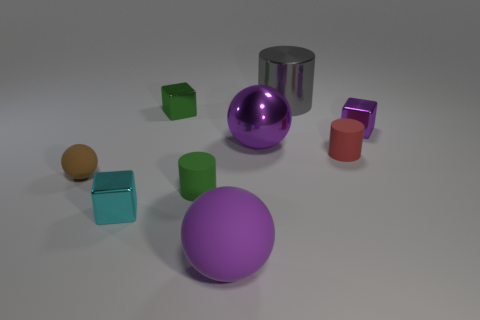What shape is the thing on the right side of the red matte cylinder?
Keep it short and to the point. Cube. There is a matte cylinder behind the cylinder in front of the red object; what color is it?
Provide a succinct answer. Red. What color is the tiny rubber thing that is the same shape as the big purple metallic thing?
Ensure brevity in your answer.  Brown. What number of shiny things are the same color as the metal sphere?
Make the answer very short. 1. There is a tiny sphere; is its color the same as the small matte cylinder behind the tiny brown rubber thing?
Your answer should be very brief. No. The small metal thing that is in front of the tiny green shiny thing and left of the red rubber object has what shape?
Keep it short and to the point. Cube. The small cube in front of the tiny green object that is in front of the cylinder that is right of the big gray shiny cylinder is made of what material?
Keep it short and to the point. Metal. Is the number of tiny brown objects behind the tiny green metallic thing greater than the number of brown rubber spheres that are on the right side of the brown matte sphere?
Keep it short and to the point. No. How many large gray cylinders are made of the same material as the green cube?
Keep it short and to the point. 1. There is a tiny rubber object that is right of the big purple rubber ball; is it the same shape as the large purple thing that is right of the purple matte sphere?
Provide a succinct answer. No. 